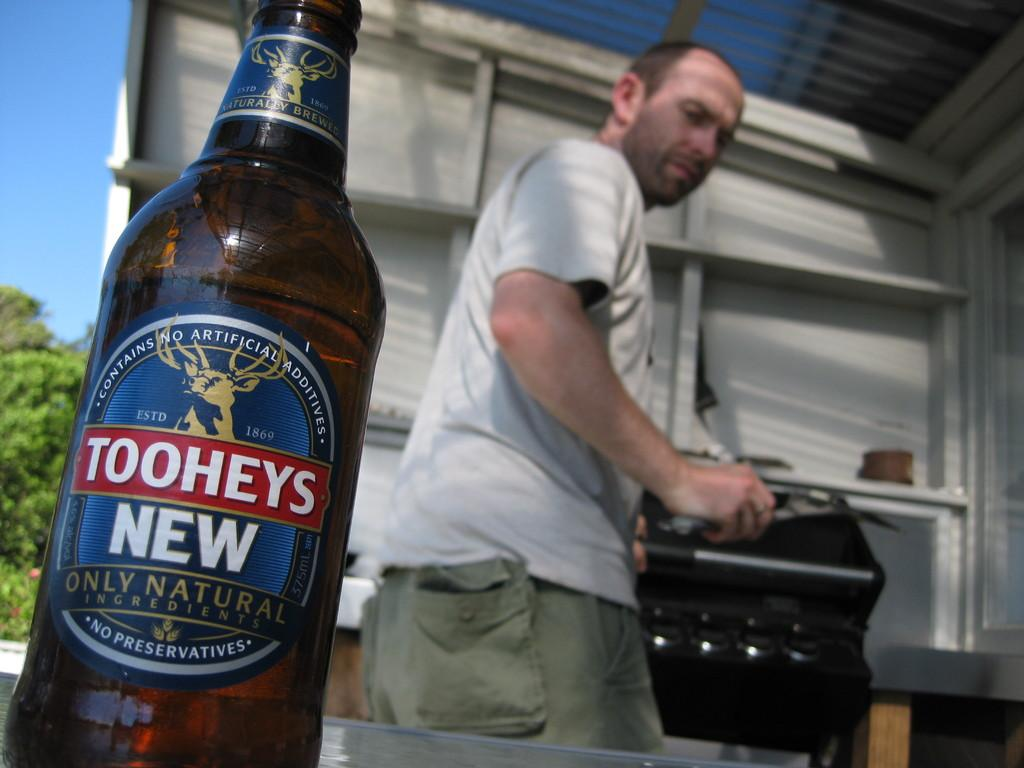<image>
Write a terse but informative summary of the picture. A man is shown behind a bottle of Tooheys New beer. 